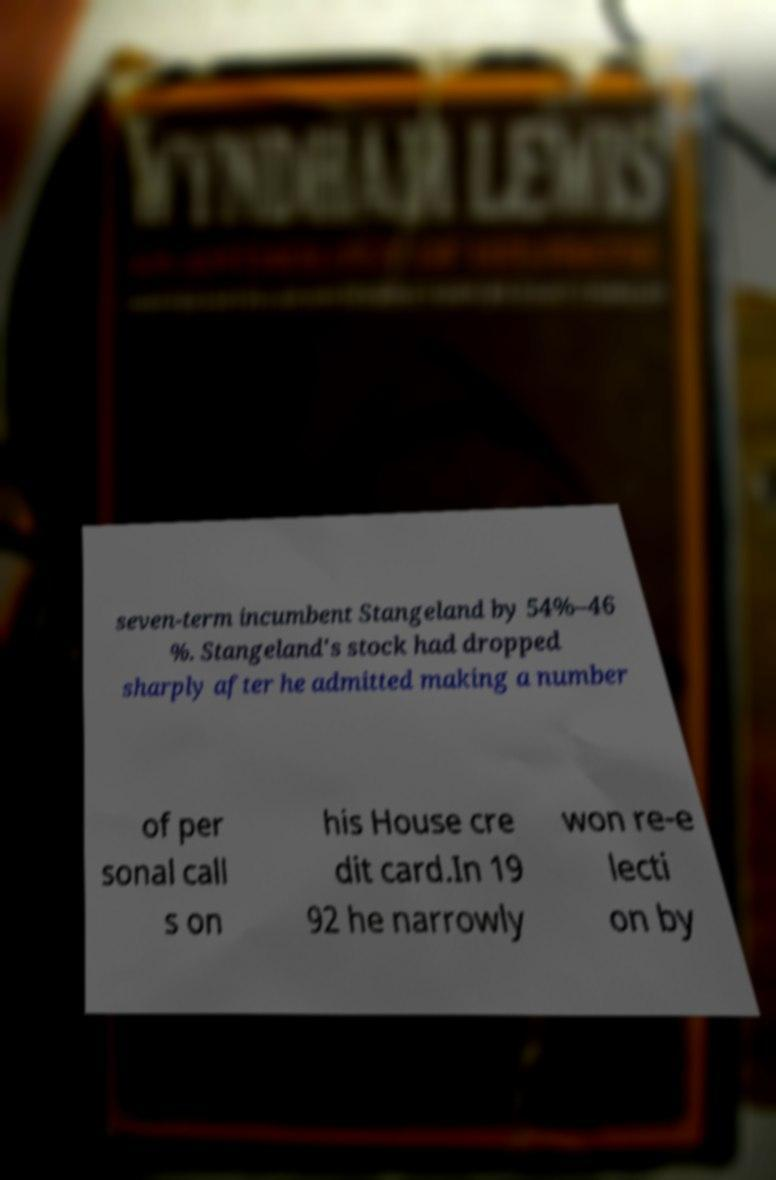I need the written content from this picture converted into text. Can you do that? seven-term incumbent Stangeland by 54%–46 %. Stangeland's stock had dropped sharply after he admitted making a number of per sonal call s on his House cre dit card.In 19 92 he narrowly won re-e lecti on by 